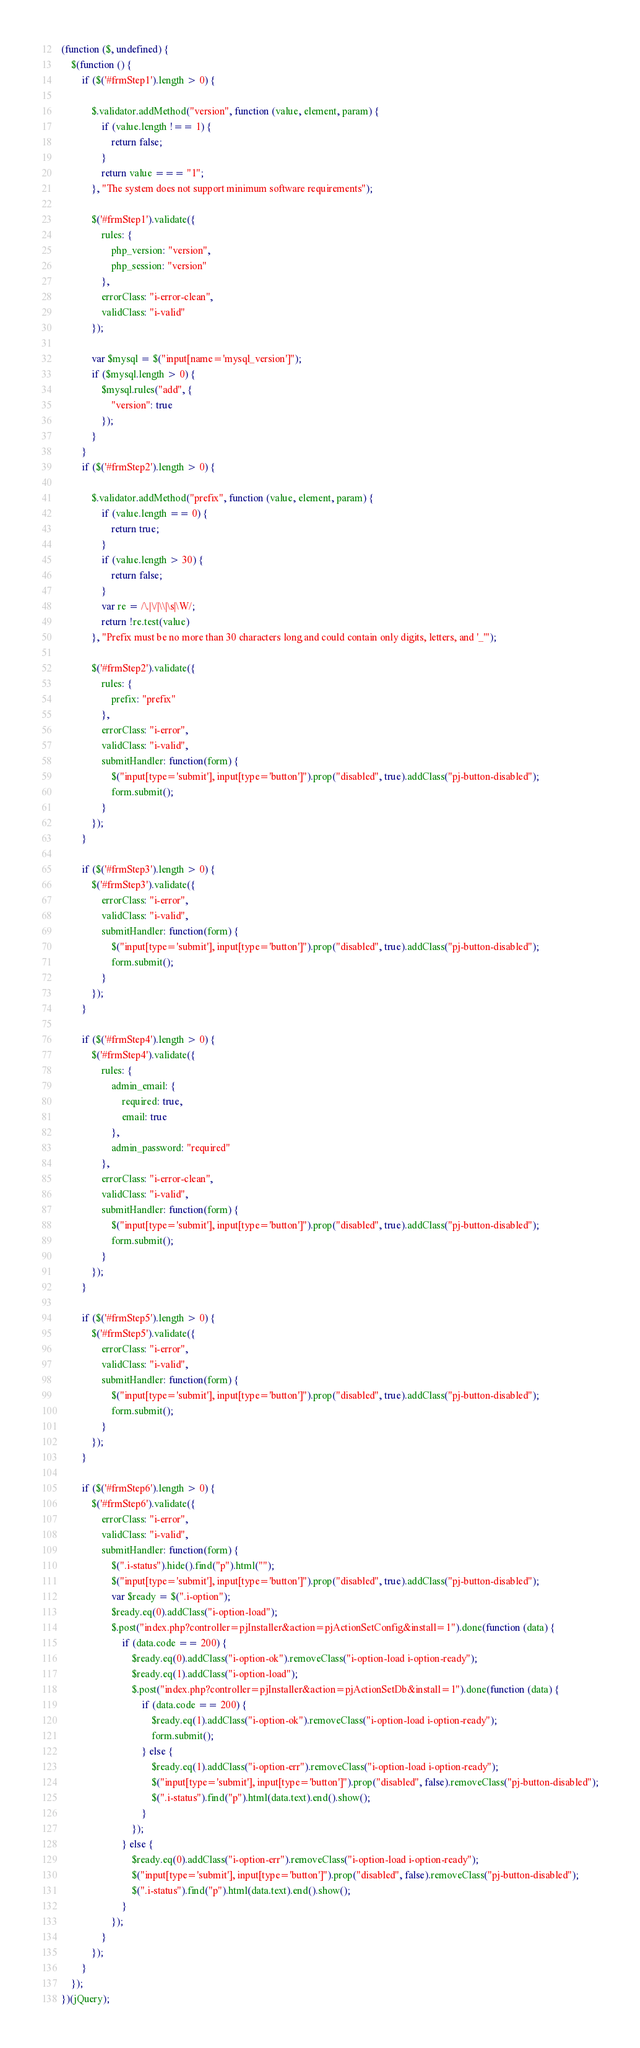Convert code to text. <code><loc_0><loc_0><loc_500><loc_500><_JavaScript_>(function ($, undefined) {
	$(function () {
		if ($('#frmStep1').length > 0) {

			$.validator.addMethod("version", function (value, element, param) {
				if (value.length !== 1) {
					return false;
				}
				return value === "1";
			}, "The system does not support minimum software requirements");
			
			$('#frmStep1').validate({
				rules: {
					php_version: "version",
					php_session: "version"
				},
				errorClass: "i-error-clean",
				validClass: "i-valid"
			});
			
			var $mysql = $("input[name='mysql_version']");
			if ($mysql.length > 0) {
				$mysql.rules("add", {
					"version": true
				});
			}
		}		
		if ($('#frmStep2').length > 0) {
			
			$.validator.addMethod("prefix", function (value, element, param) {
				if (value.length == 0) {
					return true;
				}
				if (value.length > 30) {
					return false;
				}
				var re = /\.|\/|\\|\s|\W/;
				return !re.test(value)
			}, "Prefix must be no more than 30 characters long and could contain only digits, letters, and '_'");
			
			$('#frmStep2').validate({
				rules: {
					prefix: "prefix"
				},
				errorClass: "i-error",
				validClass: "i-valid",
				submitHandler: function(form) {
					$("input[type='submit'], input[type='button']").prop("disabled", true).addClass("pj-button-disabled");
					form.submit();
				}
			});			
		}
		
		if ($('#frmStep3').length > 0) {
			$('#frmStep3').validate({
				errorClass: "i-error",
				validClass: "i-valid",
				submitHandler: function(form) {
					$("input[type='submit'], input[type='button']").prop("disabled", true).addClass("pj-button-disabled");
					form.submit();
				}				
			});			
		}
		
		if ($('#frmStep4').length > 0) {
			$('#frmStep4').validate({
				rules: {
					admin_email: {
						required: true,
						email: true
					},
					admin_password: "required"
				},
				errorClass: "i-error-clean",
				validClass: "i-valid",
				submitHandler: function(form) {
					$("input[type='submit'], input[type='button']").prop("disabled", true).addClass("pj-button-disabled");
					form.submit();
				}				
			});			
		}
		
		if ($('#frmStep5').length > 0) {
			$('#frmStep5').validate({
				errorClass: "i-error",
				validClass: "i-valid",
				submitHandler: function(form) {
					$("input[type='submit'], input[type='button']").prop("disabled", true).addClass("pj-button-disabled");
					form.submit();
				}				
			});			
		}
		
		if ($('#frmStep6').length > 0) {
			$('#frmStep6').validate({
				errorClass: "i-error",
				validClass: "i-valid",
				submitHandler: function(form) {
					$(".i-status").hide().find("p").html("");
					$("input[type='submit'], input[type='button']").prop("disabled", true).addClass("pj-button-disabled");
					var $ready = $(".i-option");
					$ready.eq(0).addClass("i-option-load");
					$.post("index.php?controller=pjInstaller&action=pjActionSetConfig&install=1").done(function (data) {
						if (data.code == 200) { 
							$ready.eq(0).addClass("i-option-ok").removeClass("i-option-load i-option-ready");
							$ready.eq(1).addClass("i-option-load");
							$.post("index.php?controller=pjInstaller&action=pjActionSetDb&install=1").done(function (data) {
								if (data.code == 200) {
									$ready.eq(1).addClass("i-option-ok").removeClass("i-option-load i-option-ready");
									form.submit();
								} else {
									$ready.eq(1).addClass("i-option-err").removeClass("i-option-load i-option-ready");
									$("input[type='submit'], input[type='button']").prop("disabled", false).removeClass("pj-button-disabled");
									$(".i-status").find("p").html(data.text).end().show();
								}
							});
						} else {
							$ready.eq(0).addClass("i-option-err").removeClass("i-option-load i-option-ready");
							$("input[type='submit'], input[type='button']").prop("disabled", false).removeClass("pj-button-disabled");
							$(".i-status").find("p").html(data.text).end().show();
						}
					});
				}				
			});			
		}
	});
})(jQuery);</code> 